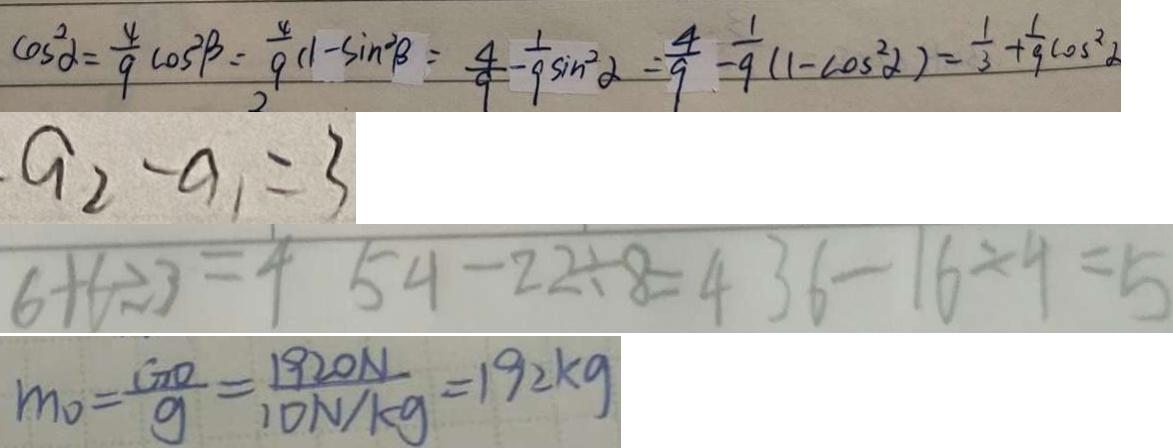Convert formula to latex. <formula><loc_0><loc_0><loc_500><loc_500>\cos ^ { 2 } \alpha = \frac { 4 } { 9 } \cos ^ { 2 } \beta = \frac { 4 } { 9 } ( 1 - \sin ^ { 2 } \beta ) = \frac { 4 } { 9 } - \frac { 1 } { 9 } \sin ^ { 2 } \alpha = \frac { 4 } { 9 } - \frac { 1 } { 9 } ( 1 - \cos ^ { 2 } \alpha ) = \frac { 1 } { 3 } + \frac { 1 } { 9 } \cos ^ { 2 } \alpha 
 \cdot a _ { 2 } - a _ { 1 } = 3 
 6 + 6 \div 3 = 4 5 4 - 2 2 \div 8 = 4 3 6 - 1 6 \div 4 = 5 
 m _ { 0 } = \frac { G O } { g } = \frac { 1 9 2 0 N } { 1 0 N / k g } = 1 9 2 k g</formula> 